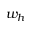<formula> <loc_0><loc_0><loc_500><loc_500>w _ { h }</formula> 